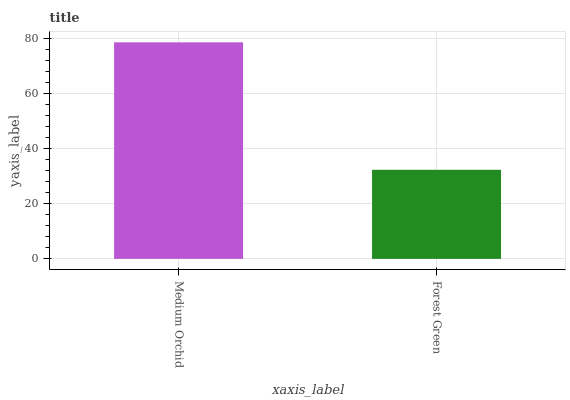Is Forest Green the minimum?
Answer yes or no. Yes. Is Medium Orchid the maximum?
Answer yes or no. Yes. Is Forest Green the maximum?
Answer yes or no. No. Is Medium Orchid greater than Forest Green?
Answer yes or no. Yes. Is Forest Green less than Medium Orchid?
Answer yes or no. Yes. Is Forest Green greater than Medium Orchid?
Answer yes or no. No. Is Medium Orchid less than Forest Green?
Answer yes or no. No. Is Medium Orchid the high median?
Answer yes or no. Yes. Is Forest Green the low median?
Answer yes or no. Yes. Is Forest Green the high median?
Answer yes or no. No. Is Medium Orchid the low median?
Answer yes or no. No. 